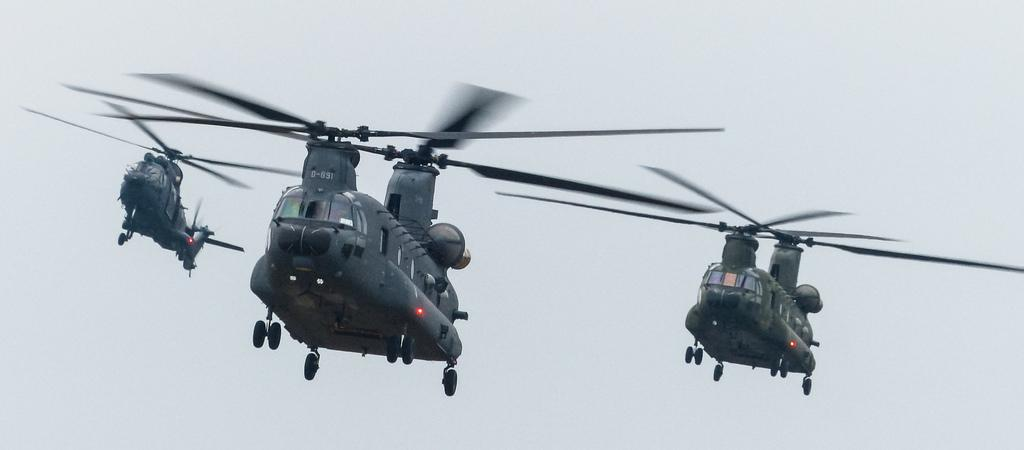What is the main subject of the image? The main subject of the image is three helicopters in the sky. What can be said about the color of the helicopters? The helicopters are grey in color. Do the helicopters have any distinguishing features? Yes, each helicopter has a unique code. How would you describe the sky in the image? The sky is clear in the image. What type of animal can be seen with a fang in the image? There is no animal with a fang present in the image; it features three grey helicopters with unique codes in a clear sky. 